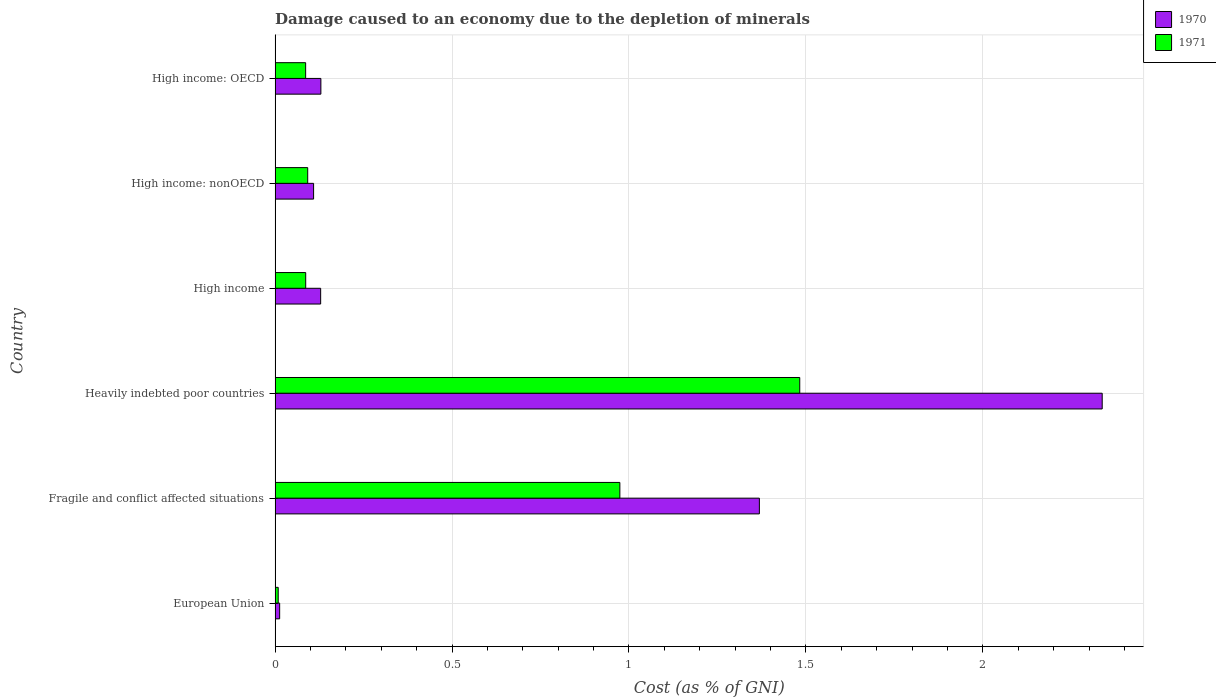How many different coloured bars are there?
Your answer should be very brief. 2. Are the number of bars per tick equal to the number of legend labels?
Make the answer very short. Yes. Are the number of bars on each tick of the Y-axis equal?
Offer a very short reply. Yes. How many bars are there on the 4th tick from the top?
Keep it short and to the point. 2. What is the label of the 6th group of bars from the top?
Offer a very short reply. European Union. In how many cases, is the number of bars for a given country not equal to the number of legend labels?
Give a very brief answer. 0. What is the cost of damage caused due to the depletion of minerals in 1970 in Fragile and conflict affected situations?
Provide a succinct answer. 1.37. Across all countries, what is the maximum cost of damage caused due to the depletion of minerals in 1971?
Provide a short and direct response. 1.48. Across all countries, what is the minimum cost of damage caused due to the depletion of minerals in 1970?
Offer a terse response. 0.01. In which country was the cost of damage caused due to the depletion of minerals in 1971 maximum?
Give a very brief answer. Heavily indebted poor countries. What is the total cost of damage caused due to the depletion of minerals in 1970 in the graph?
Make the answer very short. 4.09. What is the difference between the cost of damage caused due to the depletion of minerals in 1971 in High income and that in High income: OECD?
Your answer should be compact. 0. What is the difference between the cost of damage caused due to the depletion of minerals in 1971 in Fragile and conflict affected situations and the cost of damage caused due to the depletion of minerals in 1970 in High income: nonOECD?
Keep it short and to the point. 0.87. What is the average cost of damage caused due to the depletion of minerals in 1970 per country?
Provide a short and direct response. 0.68. What is the difference between the cost of damage caused due to the depletion of minerals in 1971 and cost of damage caused due to the depletion of minerals in 1970 in Fragile and conflict affected situations?
Keep it short and to the point. -0.39. What is the ratio of the cost of damage caused due to the depletion of minerals in 1970 in High income to that in High income: nonOECD?
Your response must be concise. 1.18. Is the difference between the cost of damage caused due to the depletion of minerals in 1971 in High income and High income: nonOECD greater than the difference between the cost of damage caused due to the depletion of minerals in 1970 in High income and High income: nonOECD?
Offer a very short reply. No. What is the difference between the highest and the second highest cost of damage caused due to the depletion of minerals in 1970?
Offer a very short reply. 0.97. What is the difference between the highest and the lowest cost of damage caused due to the depletion of minerals in 1971?
Your response must be concise. 1.47. Are the values on the major ticks of X-axis written in scientific E-notation?
Give a very brief answer. No. Does the graph contain grids?
Make the answer very short. Yes. How many legend labels are there?
Ensure brevity in your answer.  2. How are the legend labels stacked?
Give a very brief answer. Vertical. What is the title of the graph?
Your answer should be very brief. Damage caused to an economy due to the depletion of minerals. What is the label or title of the X-axis?
Provide a succinct answer. Cost (as % of GNI). What is the label or title of the Y-axis?
Provide a succinct answer. Country. What is the Cost (as % of GNI) of 1970 in European Union?
Give a very brief answer. 0.01. What is the Cost (as % of GNI) in 1971 in European Union?
Offer a very short reply. 0.01. What is the Cost (as % of GNI) in 1970 in Fragile and conflict affected situations?
Your answer should be very brief. 1.37. What is the Cost (as % of GNI) in 1971 in Fragile and conflict affected situations?
Offer a terse response. 0.97. What is the Cost (as % of GNI) of 1970 in Heavily indebted poor countries?
Ensure brevity in your answer.  2.34. What is the Cost (as % of GNI) in 1971 in Heavily indebted poor countries?
Give a very brief answer. 1.48. What is the Cost (as % of GNI) of 1970 in High income?
Give a very brief answer. 0.13. What is the Cost (as % of GNI) of 1971 in High income?
Keep it short and to the point. 0.09. What is the Cost (as % of GNI) of 1970 in High income: nonOECD?
Your answer should be very brief. 0.11. What is the Cost (as % of GNI) in 1971 in High income: nonOECD?
Keep it short and to the point. 0.09. What is the Cost (as % of GNI) of 1970 in High income: OECD?
Offer a terse response. 0.13. What is the Cost (as % of GNI) in 1971 in High income: OECD?
Provide a succinct answer. 0.09. Across all countries, what is the maximum Cost (as % of GNI) in 1970?
Make the answer very short. 2.34. Across all countries, what is the maximum Cost (as % of GNI) in 1971?
Provide a succinct answer. 1.48. Across all countries, what is the minimum Cost (as % of GNI) of 1970?
Provide a short and direct response. 0.01. Across all countries, what is the minimum Cost (as % of GNI) in 1971?
Give a very brief answer. 0.01. What is the total Cost (as % of GNI) in 1970 in the graph?
Your answer should be compact. 4.09. What is the total Cost (as % of GNI) in 1971 in the graph?
Provide a succinct answer. 2.73. What is the difference between the Cost (as % of GNI) of 1970 in European Union and that in Fragile and conflict affected situations?
Provide a succinct answer. -1.36. What is the difference between the Cost (as % of GNI) of 1971 in European Union and that in Fragile and conflict affected situations?
Your answer should be very brief. -0.97. What is the difference between the Cost (as % of GNI) of 1970 in European Union and that in Heavily indebted poor countries?
Your response must be concise. -2.32. What is the difference between the Cost (as % of GNI) of 1971 in European Union and that in Heavily indebted poor countries?
Provide a short and direct response. -1.47. What is the difference between the Cost (as % of GNI) of 1970 in European Union and that in High income?
Ensure brevity in your answer.  -0.12. What is the difference between the Cost (as % of GNI) in 1971 in European Union and that in High income?
Provide a short and direct response. -0.08. What is the difference between the Cost (as % of GNI) of 1970 in European Union and that in High income: nonOECD?
Your response must be concise. -0.1. What is the difference between the Cost (as % of GNI) of 1971 in European Union and that in High income: nonOECD?
Provide a short and direct response. -0.08. What is the difference between the Cost (as % of GNI) in 1970 in European Union and that in High income: OECD?
Provide a short and direct response. -0.12. What is the difference between the Cost (as % of GNI) of 1971 in European Union and that in High income: OECD?
Offer a terse response. -0.08. What is the difference between the Cost (as % of GNI) in 1970 in Fragile and conflict affected situations and that in Heavily indebted poor countries?
Your answer should be very brief. -0.97. What is the difference between the Cost (as % of GNI) in 1971 in Fragile and conflict affected situations and that in Heavily indebted poor countries?
Provide a succinct answer. -0.51. What is the difference between the Cost (as % of GNI) of 1970 in Fragile and conflict affected situations and that in High income?
Make the answer very short. 1.24. What is the difference between the Cost (as % of GNI) in 1971 in Fragile and conflict affected situations and that in High income?
Keep it short and to the point. 0.89. What is the difference between the Cost (as % of GNI) in 1970 in Fragile and conflict affected situations and that in High income: nonOECD?
Give a very brief answer. 1.26. What is the difference between the Cost (as % of GNI) of 1971 in Fragile and conflict affected situations and that in High income: nonOECD?
Provide a short and direct response. 0.88. What is the difference between the Cost (as % of GNI) in 1970 in Fragile and conflict affected situations and that in High income: OECD?
Your answer should be compact. 1.24. What is the difference between the Cost (as % of GNI) of 1971 in Fragile and conflict affected situations and that in High income: OECD?
Ensure brevity in your answer.  0.89. What is the difference between the Cost (as % of GNI) of 1970 in Heavily indebted poor countries and that in High income?
Your answer should be compact. 2.21. What is the difference between the Cost (as % of GNI) in 1971 in Heavily indebted poor countries and that in High income?
Keep it short and to the point. 1.4. What is the difference between the Cost (as % of GNI) in 1970 in Heavily indebted poor countries and that in High income: nonOECD?
Offer a very short reply. 2.23. What is the difference between the Cost (as % of GNI) of 1971 in Heavily indebted poor countries and that in High income: nonOECD?
Give a very brief answer. 1.39. What is the difference between the Cost (as % of GNI) in 1970 in Heavily indebted poor countries and that in High income: OECD?
Make the answer very short. 2.21. What is the difference between the Cost (as % of GNI) in 1971 in Heavily indebted poor countries and that in High income: OECD?
Offer a very short reply. 1.4. What is the difference between the Cost (as % of GNI) in 1971 in High income and that in High income: nonOECD?
Keep it short and to the point. -0.01. What is the difference between the Cost (as % of GNI) in 1970 in High income and that in High income: OECD?
Ensure brevity in your answer.  -0. What is the difference between the Cost (as % of GNI) of 1971 in High income and that in High income: OECD?
Make the answer very short. 0. What is the difference between the Cost (as % of GNI) of 1970 in High income: nonOECD and that in High income: OECD?
Your response must be concise. -0.02. What is the difference between the Cost (as % of GNI) of 1971 in High income: nonOECD and that in High income: OECD?
Make the answer very short. 0.01. What is the difference between the Cost (as % of GNI) of 1970 in European Union and the Cost (as % of GNI) of 1971 in Fragile and conflict affected situations?
Keep it short and to the point. -0.96. What is the difference between the Cost (as % of GNI) in 1970 in European Union and the Cost (as % of GNI) in 1971 in Heavily indebted poor countries?
Provide a succinct answer. -1.47. What is the difference between the Cost (as % of GNI) of 1970 in European Union and the Cost (as % of GNI) of 1971 in High income?
Make the answer very short. -0.07. What is the difference between the Cost (as % of GNI) in 1970 in European Union and the Cost (as % of GNI) in 1971 in High income: nonOECD?
Your answer should be very brief. -0.08. What is the difference between the Cost (as % of GNI) in 1970 in European Union and the Cost (as % of GNI) in 1971 in High income: OECD?
Make the answer very short. -0.07. What is the difference between the Cost (as % of GNI) in 1970 in Fragile and conflict affected situations and the Cost (as % of GNI) in 1971 in Heavily indebted poor countries?
Offer a terse response. -0.11. What is the difference between the Cost (as % of GNI) in 1970 in Fragile and conflict affected situations and the Cost (as % of GNI) in 1971 in High income?
Give a very brief answer. 1.28. What is the difference between the Cost (as % of GNI) in 1970 in Fragile and conflict affected situations and the Cost (as % of GNI) in 1971 in High income: nonOECD?
Offer a terse response. 1.28. What is the difference between the Cost (as % of GNI) in 1970 in Fragile and conflict affected situations and the Cost (as % of GNI) in 1971 in High income: OECD?
Offer a terse response. 1.28. What is the difference between the Cost (as % of GNI) in 1970 in Heavily indebted poor countries and the Cost (as % of GNI) in 1971 in High income?
Provide a short and direct response. 2.25. What is the difference between the Cost (as % of GNI) of 1970 in Heavily indebted poor countries and the Cost (as % of GNI) of 1971 in High income: nonOECD?
Give a very brief answer. 2.25. What is the difference between the Cost (as % of GNI) in 1970 in Heavily indebted poor countries and the Cost (as % of GNI) in 1971 in High income: OECD?
Your answer should be compact. 2.25. What is the difference between the Cost (as % of GNI) of 1970 in High income and the Cost (as % of GNI) of 1971 in High income: nonOECD?
Ensure brevity in your answer.  0.04. What is the difference between the Cost (as % of GNI) in 1970 in High income and the Cost (as % of GNI) in 1971 in High income: OECD?
Offer a terse response. 0.04. What is the difference between the Cost (as % of GNI) in 1970 in High income: nonOECD and the Cost (as % of GNI) in 1971 in High income: OECD?
Ensure brevity in your answer.  0.02. What is the average Cost (as % of GNI) in 1970 per country?
Your response must be concise. 0.68. What is the average Cost (as % of GNI) of 1971 per country?
Your answer should be compact. 0.46. What is the difference between the Cost (as % of GNI) of 1970 and Cost (as % of GNI) of 1971 in European Union?
Keep it short and to the point. 0. What is the difference between the Cost (as % of GNI) of 1970 and Cost (as % of GNI) of 1971 in Fragile and conflict affected situations?
Your answer should be very brief. 0.39. What is the difference between the Cost (as % of GNI) of 1970 and Cost (as % of GNI) of 1971 in Heavily indebted poor countries?
Keep it short and to the point. 0.85. What is the difference between the Cost (as % of GNI) in 1970 and Cost (as % of GNI) in 1971 in High income?
Your answer should be compact. 0.04. What is the difference between the Cost (as % of GNI) in 1970 and Cost (as % of GNI) in 1971 in High income: nonOECD?
Provide a succinct answer. 0.02. What is the difference between the Cost (as % of GNI) of 1970 and Cost (as % of GNI) of 1971 in High income: OECD?
Your answer should be very brief. 0.04. What is the ratio of the Cost (as % of GNI) of 1970 in European Union to that in Fragile and conflict affected situations?
Your response must be concise. 0.01. What is the ratio of the Cost (as % of GNI) of 1971 in European Union to that in Fragile and conflict affected situations?
Offer a very short reply. 0.01. What is the ratio of the Cost (as % of GNI) in 1970 in European Union to that in Heavily indebted poor countries?
Your response must be concise. 0.01. What is the ratio of the Cost (as % of GNI) of 1971 in European Union to that in Heavily indebted poor countries?
Offer a very short reply. 0.01. What is the ratio of the Cost (as % of GNI) of 1970 in European Union to that in High income?
Your response must be concise. 0.1. What is the ratio of the Cost (as % of GNI) in 1971 in European Union to that in High income?
Provide a succinct answer. 0.1. What is the ratio of the Cost (as % of GNI) of 1970 in European Union to that in High income: nonOECD?
Your answer should be very brief. 0.12. What is the ratio of the Cost (as % of GNI) in 1971 in European Union to that in High income: nonOECD?
Make the answer very short. 0.1. What is the ratio of the Cost (as % of GNI) in 1970 in European Union to that in High income: OECD?
Give a very brief answer. 0.1. What is the ratio of the Cost (as % of GNI) in 1971 in European Union to that in High income: OECD?
Offer a very short reply. 0.1. What is the ratio of the Cost (as % of GNI) in 1970 in Fragile and conflict affected situations to that in Heavily indebted poor countries?
Your answer should be compact. 0.59. What is the ratio of the Cost (as % of GNI) in 1971 in Fragile and conflict affected situations to that in Heavily indebted poor countries?
Your response must be concise. 0.66. What is the ratio of the Cost (as % of GNI) of 1970 in Fragile and conflict affected situations to that in High income?
Your answer should be very brief. 10.63. What is the ratio of the Cost (as % of GNI) of 1971 in Fragile and conflict affected situations to that in High income?
Your answer should be very brief. 11.26. What is the ratio of the Cost (as % of GNI) of 1970 in Fragile and conflict affected situations to that in High income: nonOECD?
Your answer should be very brief. 12.57. What is the ratio of the Cost (as % of GNI) of 1971 in Fragile and conflict affected situations to that in High income: nonOECD?
Offer a terse response. 10.57. What is the ratio of the Cost (as % of GNI) of 1970 in Fragile and conflict affected situations to that in High income: OECD?
Make the answer very short. 10.57. What is the ratio of the Cost (as % of GNI) of 1971 in Fragile and conflict affected situations to that in High income: OECD?
Make the answer very short. 11.28. What is the ratio of the Cost (as % of GNI) in 1970 in Heavily indebted poor countries to that in High income?
Your answer should be compact. 18.15. What is the ratio of the Cost (as % of GNI) in 1971 in Heavily indebted poor countries to that in High income?
Give a very brief answer. 17.13. What is the ratio of the Cost (as % of GNI) in 1970 in Heavily indebted poor countries to that in High income: nonOECD?
Provide a succinct answer. 21.48. What is the ratio of the Cost (as % of GNI) of 1971 in Heavily indebted poor countries to that in High income: nonOECD?
Offer a very short reply. 16.08. What is the ratio of the Cost (as % of GNI) of 1970 in Heavily indebted poor countries to that in High income: OECD?
Provide a succinct answer. 18.06. What is the ratio of the Cost (as % of GNI) of 1971 in Heavily indebted poor countries to that in High income: OECD?
Provide a short and direct response. 17.17. What is the ratio of the Cost (as % of GNI) in 1970 in High income to that in High income: nonOECD?
Make the answer very short. 1.18. What is the ratio of the Cost (as % of GNI) in 1971 in High income to that in High income: nonOECD?
Ensure brevity in your answer.  0.94. What is the ratio of the Cost (as % of GNI) of 1970 in High income: nonOECD to that in High income: OECD?
Offer a terse response. 0.84. What is the ratio of the Cost (as % of GNI) of 1971 in High income: nonOECD to that in High income: OECD?
Provide a succinct answer. 1.07. What is the difference between the highest and the second highest Cost (as % of GNI) of 1970?
Your answer should be compact. 0.97. What is the difference between the highest and the second highest Cost (as % of GNI) in 1971?
Your answer should be very brief. 0.51. What is the difference between the highest and the lowest Cost (as % of GNI) in 1970?
Your answer should be compact. 2.32. What is the difference between the highest and the lowest Cost (as % of GNI) of 1971?
Make the answer very short. 1.47. 